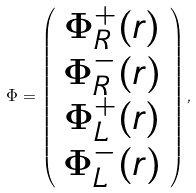Convert formula to latex. <formula><loc_0><loc_0><loc_500><loc_500>\Phi = \left ( \begin{array} { c } \Phi ^ { + } _ { R } ( r ) \\ \Phi ^ { - } _ { R } ( r ) \\ \Phi ^ { + } _ { L } ( r ) \\ \Phi ^ { - } _ { L } ( r ) \end{array} \right ) ,</formula> 